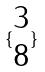Convert formula to latex. <formula><loc_0><loc_0><loc_500><loc_500>\{ \begin{matrix} 3 \\ 8 \end{matrix} \}</formula> 